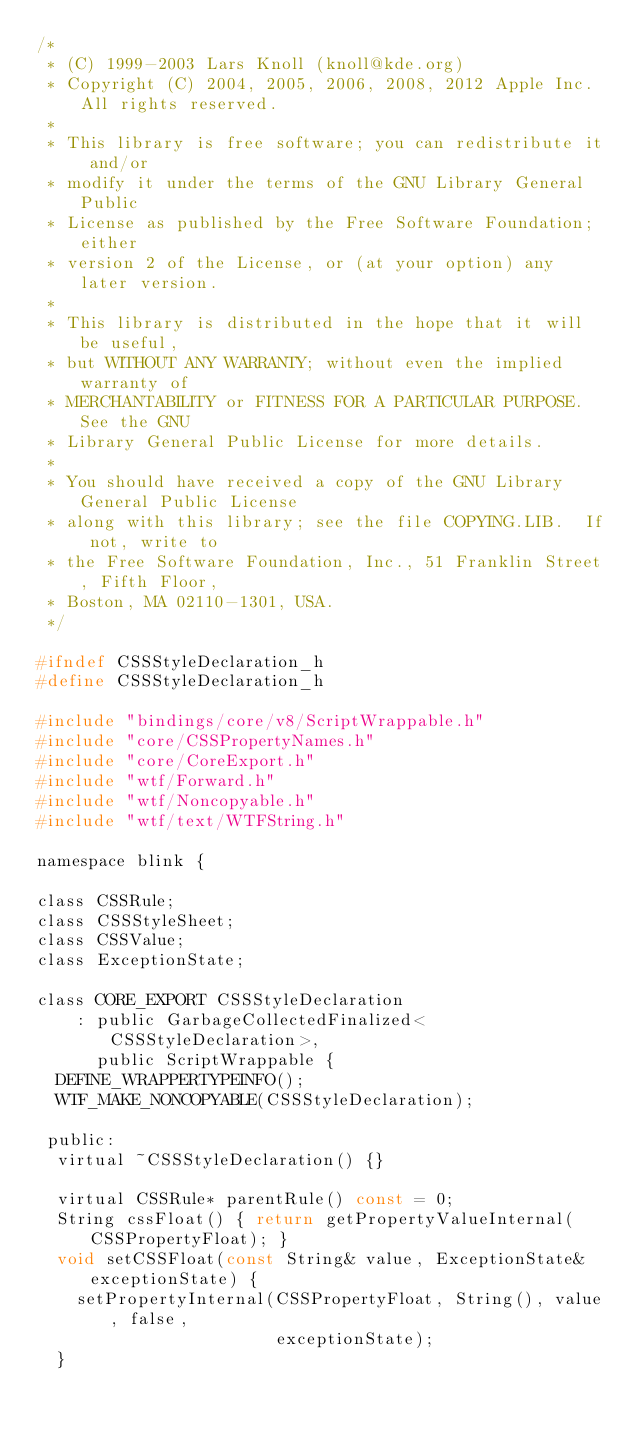Convert code to text. <code><loc_0><loc_0><loc_500><loc_500><_C_>/*
 * (C) 1999-2003 Lars Knoll (knoll@kde.org)
 * Copyright (C) 2004, 2005, 2006, 2008, 2012 Apple Inc. All rights reserved.
 *
 * This library is free software; you can redistribute it and/or
 * modify it under the terms of the GNU Library General Public
 * License as published by the Free Software Foundation; either
 * version 2 of the License, or (at your option) any later version.
 *
 * This library is distributed in the hope that it will be useful,
 * but WITHOUT ANY WARRANTY; without even the implied warranty of
 * MERCHANTABILITY or FITNESS FOR A PARTICULAR PURPOSE.  See the GNU
 * Library General Public License for more details.
 *
 * You should have received a copy of the GNU Library General Public License
 * along with this library; see the file COPYING.LIB.  If not, write to
 * the Free Software Foundation, Inc., 51 Franklin Street, Fifth Floor,
 * Boston, MA 02110-1301, USA.
 */

#ifndef CSSStyleDeclaration_h
#define CSSStyleDeclaration_h

#include "bindings/core/v8/ScriptWrappable.h"
#include "core/CSSPropertyNames.h"
#include "core/CoreExport.h"
#include "wtf/Forward.h"
#include "wtf/Noncopyable.h"
#include "wtf/text/WTFString.h"

namespace blink {

class CSSRule;
class CSSStyleSheet;
class CSSValue;
class ExceptionState;

class CORE_EXPORT CSSStyleDeclaration
    : public GarbageCollectedFinalized<CSSStyleDeclaration>,
      public ScriptWrappable {
  DEFINE_WRAPPERTYPEINFO();
  WTF_MAKE_NONCOPYABLE(CSSStyleDeclaration);

 public:
  virtual ~CSSStyleDeclaration() {}

  virtual CSSRule* parentRule() const = 0;
  String cssFloat() { return getPropertyValueInternal(CSSPropertyFloat); }
  void setCSSFloat(const String& value, ExceptionState& exceptionState) {
    setPropertyInternal(CSSPropertyFloat, String(), value, false,
                        exceptionState);
  }</code> 